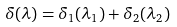Convert formula to latex. <formula><loc_0><loc_0><loc_500><loc_500>\delta ( \lambda ) = \delta _ { 1 } ( \lambda _ { 1 } ) + \delta _ { 2 } ( \lambda _ { 2 } )</formula> 